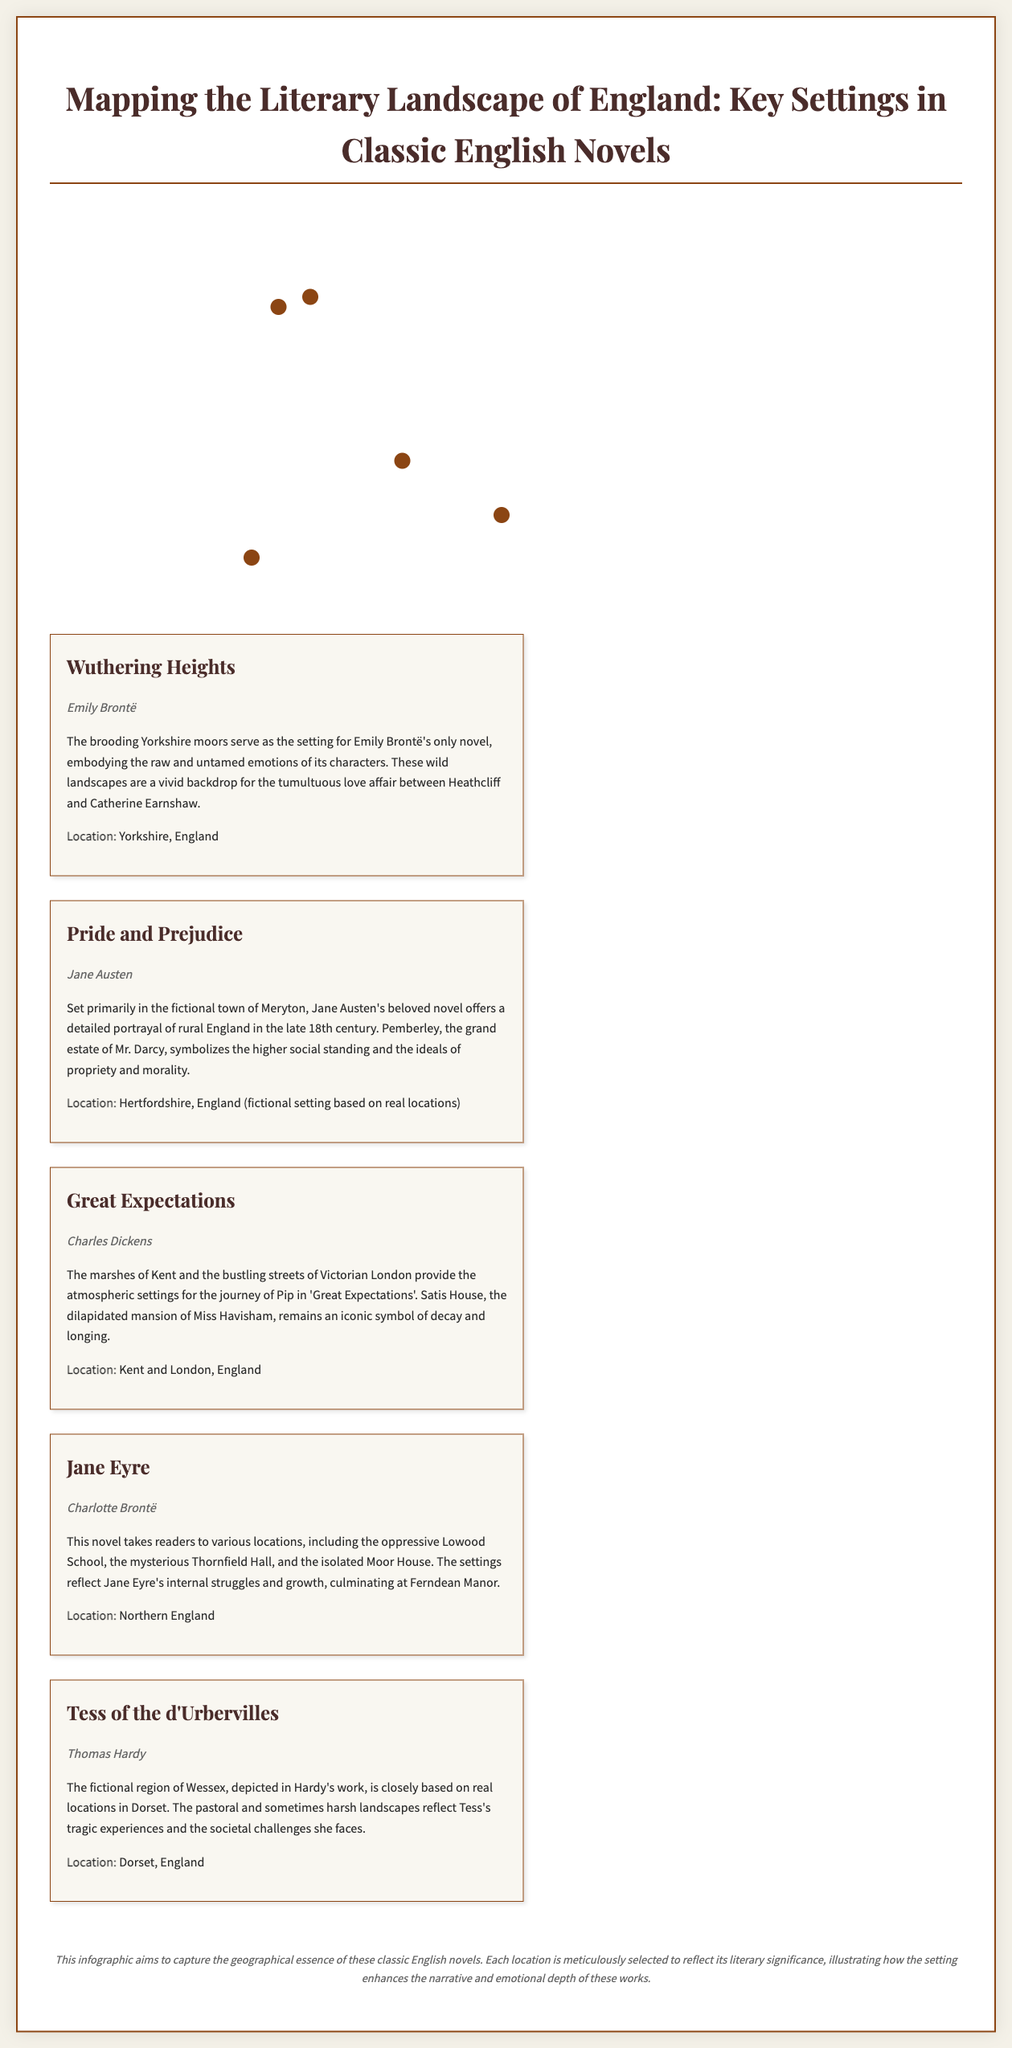What novel is set in the Yorkshire moors? The document states that "Wuthering Heights" is set in the Yorkshire moors, which embody the raw emotions of its characters.
Answer: Wuthering Heights Who is the author of "Pride and Prejudice"? The document clearly indicates that the author of "Pride and Prejudice" is Jane Austen.
Answer: Jane Austen What fictional town is primarily featured in "Pride and Prejudice"? The document mentions that the primary setting of "Pride and Prejudice" is the fictional town of Meryton.
Answer: Meryton Which novel features Satis House? The document specifies that "Great Expectations" includes the dilapidated mansion called Satis House, which symbolizes decay and longing.
Answer: Great Expectations In which English region is Tess's story set? According to the document, "Tess of the d'Urbervilles" is set in the fictional region of Wessex, based on real locations in Dorset.
Answer: Wessex What type of document is "Mapping the Literary Landscape of England"? The document is identified as a geographic infographic that maps key settings in classic English novels.
Answer: Geographic infographic How many novels are featured in the infographic? The document lists five classic English novels along with their key settings.
Answer: Five What does the infographic aim to illustrate about these classic novels? The document states that it aims to capture the geographical essence of these novels and how the settings enhance the narrative.
Answer: Geographical essence 